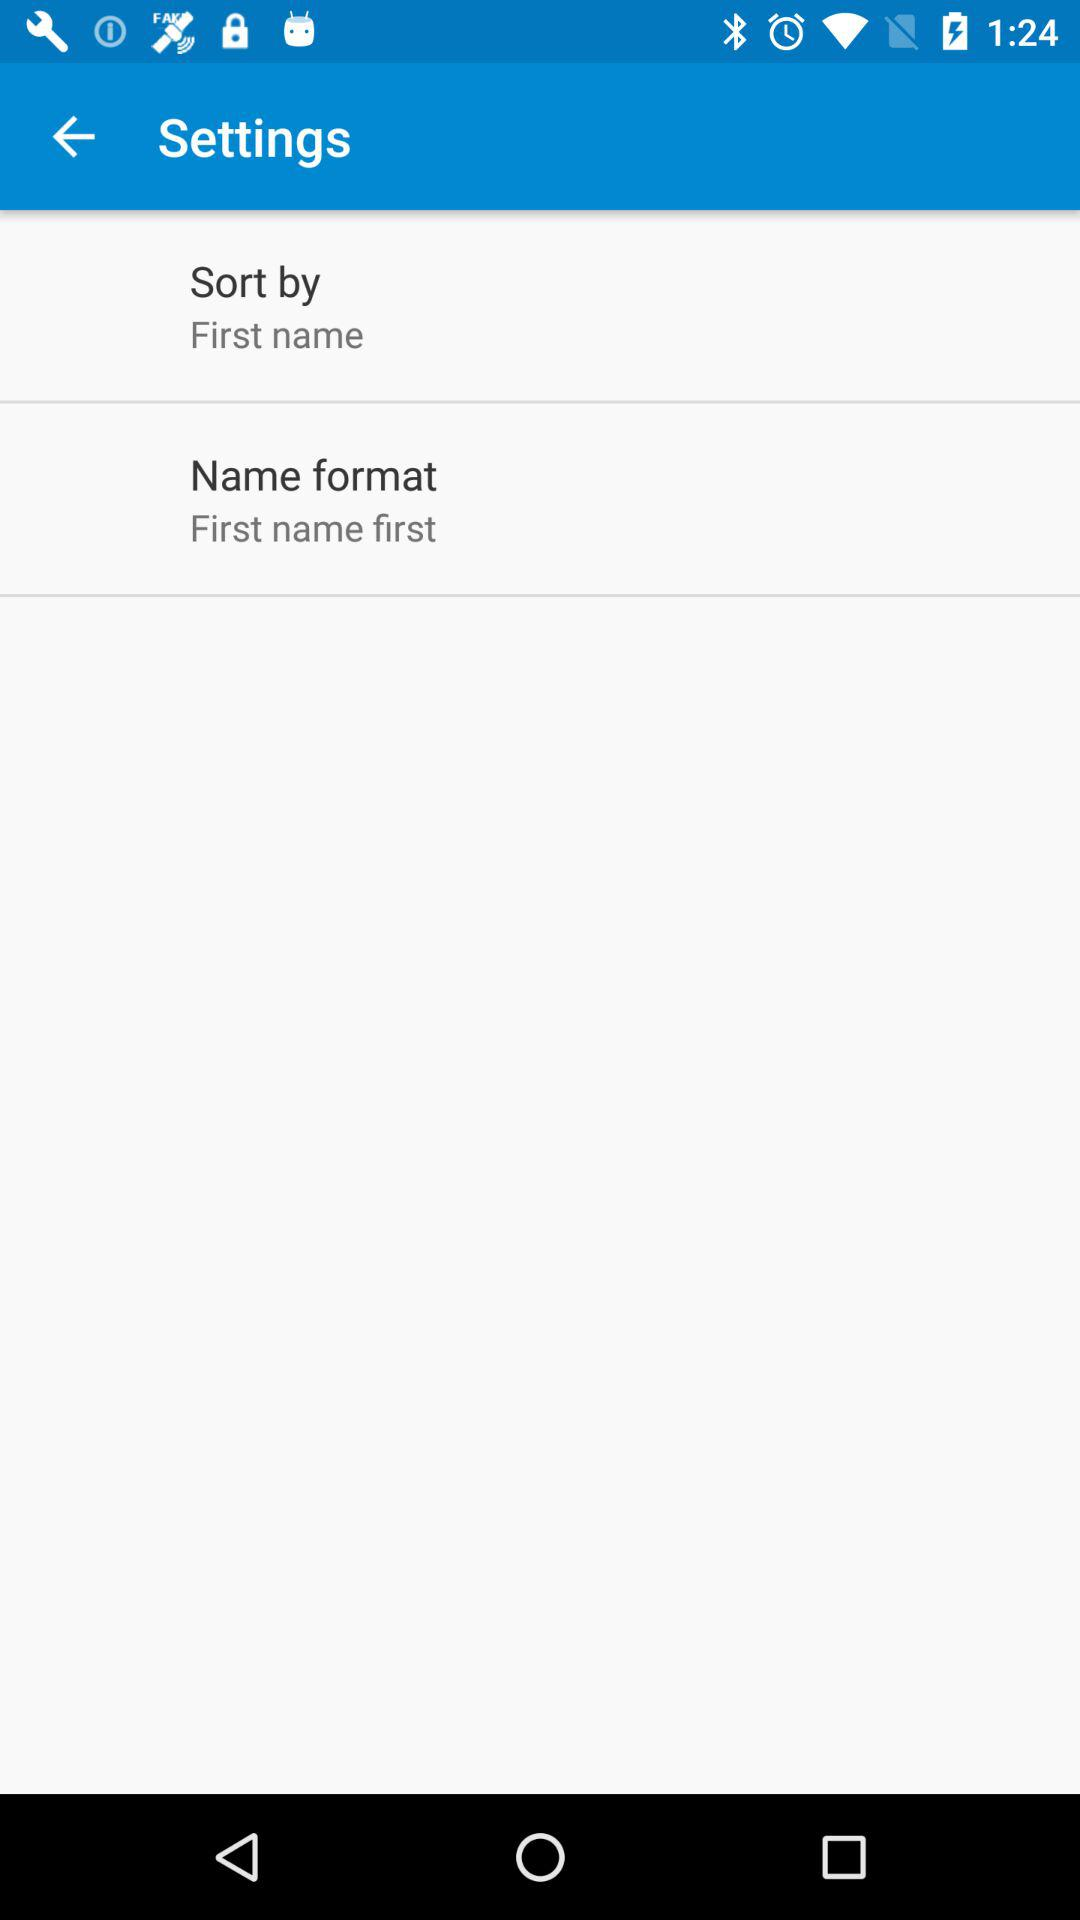What is the name format? The name format is "First name first". 